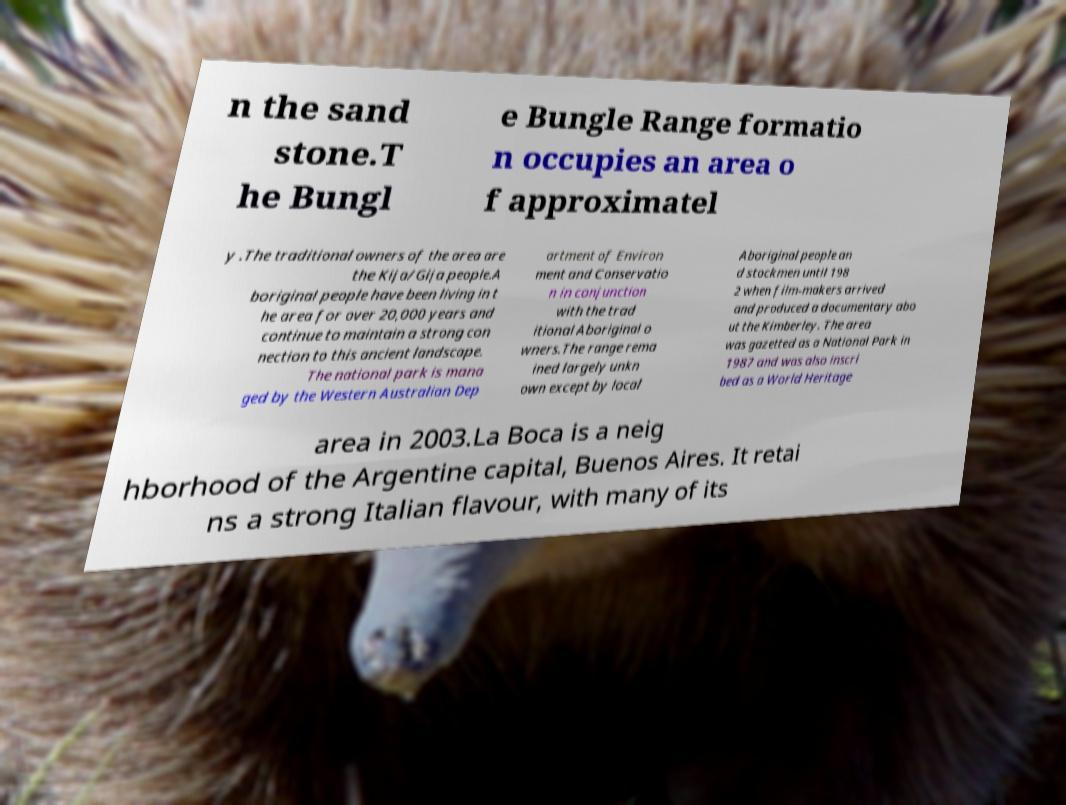There's text embedded in this image that I need extracted. Can you transcribe it verbatim? n the sand stone.T he Bungl e Bungle Range formatio n occupies an area o f approximatel y .The traditional owners of the area are the Kija/Gija people.A boriginal people have been living in t he area for over 20,000 years and continue to maintain a strong con nection to this ancient landscape. The national park is mana ged by the Western Australian Dep artment of Environ ment and Conservatio n in conjunction with the trad itional Aboriginal o wners.The range rema ined largely unkn own except by local Aboriginal people an d stockmen until 198 2 when film-makers arrived and produced a documentary abo ut the Kimberley. The area was gazetted as a National Park in 1987 and was also inscri bed as a World Heritage area in 2003.La Boca is a neig hborhood of the Argentine capital, Buenos Aires. It retai ns a strong Italian flavour, with many of its 